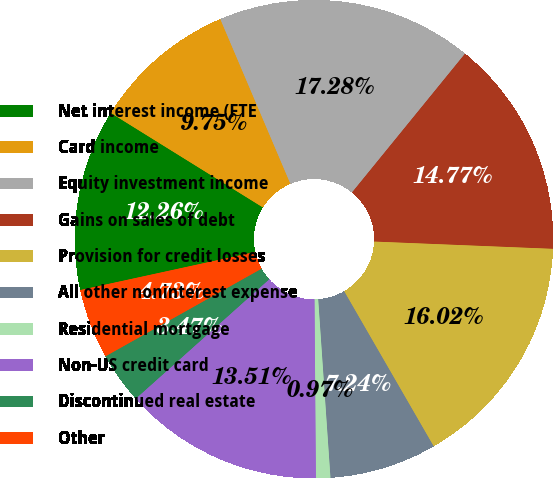Convert chart. <chart><loc_0><loc_0><loc_500><loc_500><pie_chart><fcel>Net interest income (FTE<fcel>Card income<fcel>Equity investment income<fcel>Gains on sales of debt<fcel>Provision for credit losses<fcel>All other noninterest expense<fcel>Residential mortgage<fcel>Non-US credit card<fcel>Discontinued real estate<fcel>Other<nl><fcel>12.26%<fcel>9.75%<fcel>17.28%<fcel>14.77%<fcel>16.02%<fcel>7.24%<fcel>0.97%<fcel>13.51%<fcel>3.47%<fcel>4.73%<nl></chart> 